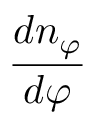Convert formula to latex. <formula><loc_0><loc_0><loc_500><loc_500>{ \frac { d n _ { \varphi } } { d \varphi } }</formula> 